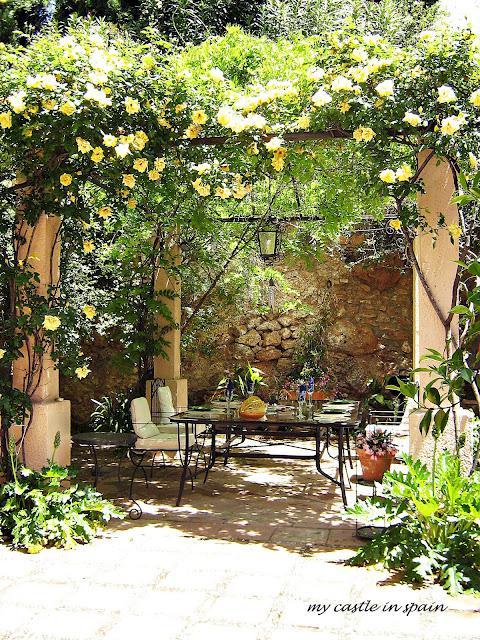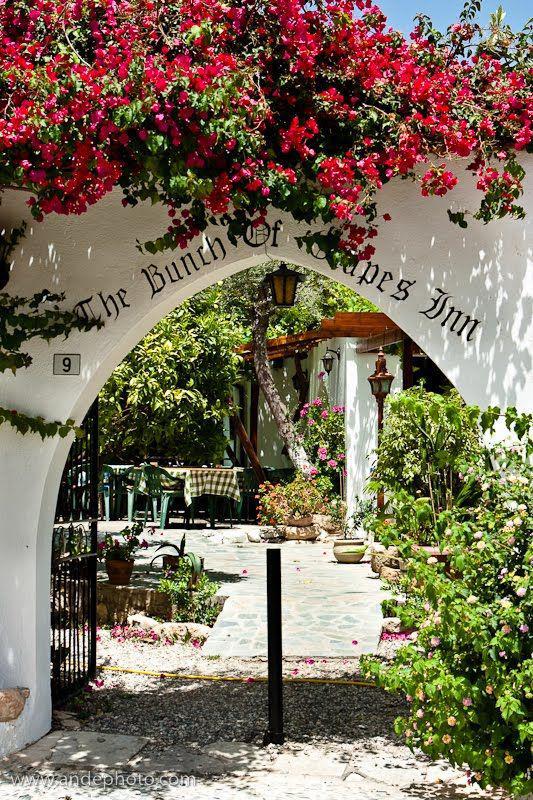The first image is the image on the left, the second image is the image on the right. Assess this claim about the two images: "The left and right image each contain at least five square light brown wooden dining tables.". Correct or not? Answer yes or no. No. The first image is the image on the left, the second image is the image on the right. Assess this claim about the two images: "At least one restaurant's tables are sitting outdoors in the open air.". Correct or not? Answer yes or no. Yes. 